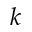Convert formula to latex. <formula><loc_0><loc_0><loc_500><loc_500>k</formula> 